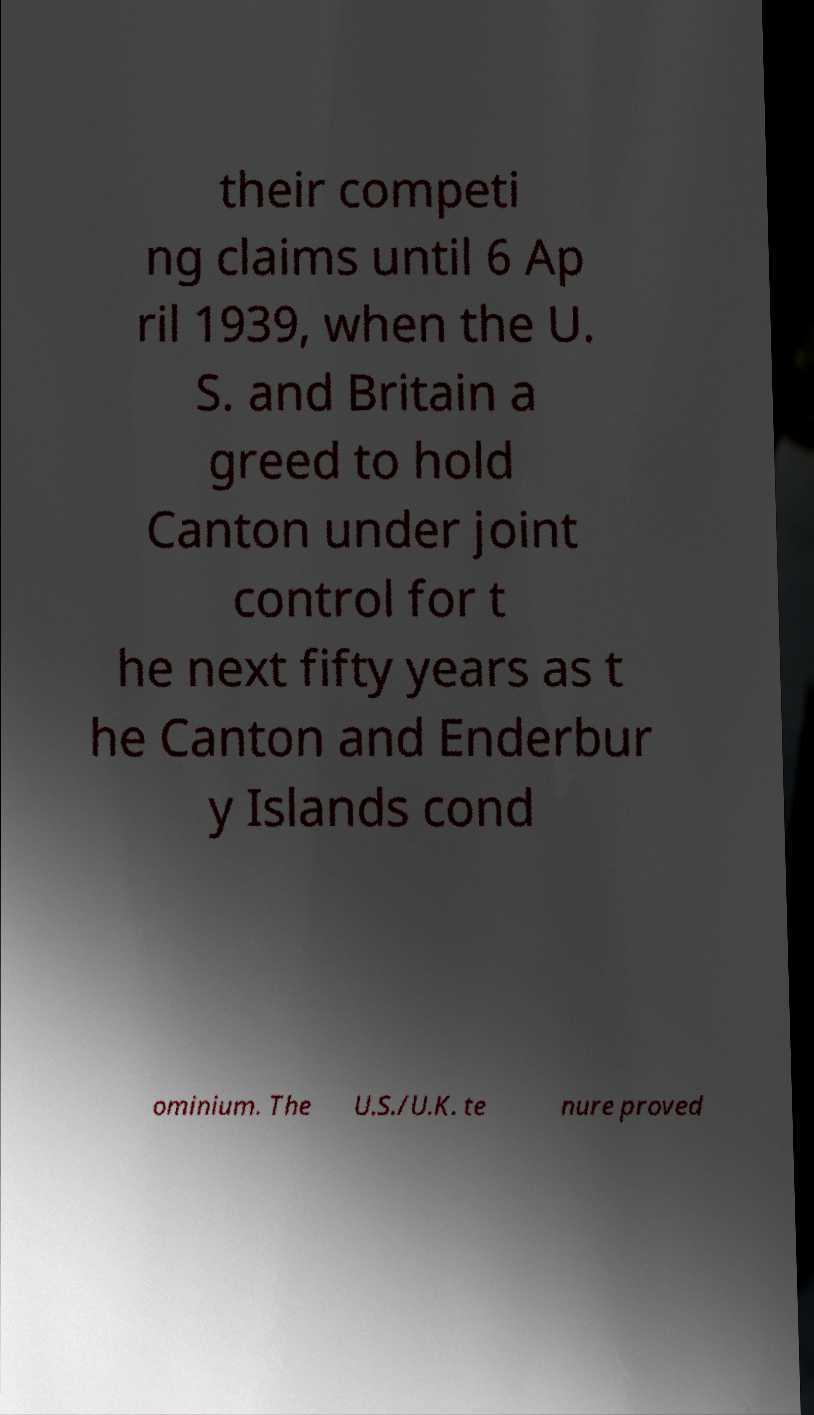Could you extract and type out the text from this image? their competi ng claims until 6 Ap ril 1939, when the U. S. and Britain a greed to hold Canton under joint control for t he next fifty years as t he Canton and Enderbur y Islands cond ominium. The U.S./U.K. te nure proved 